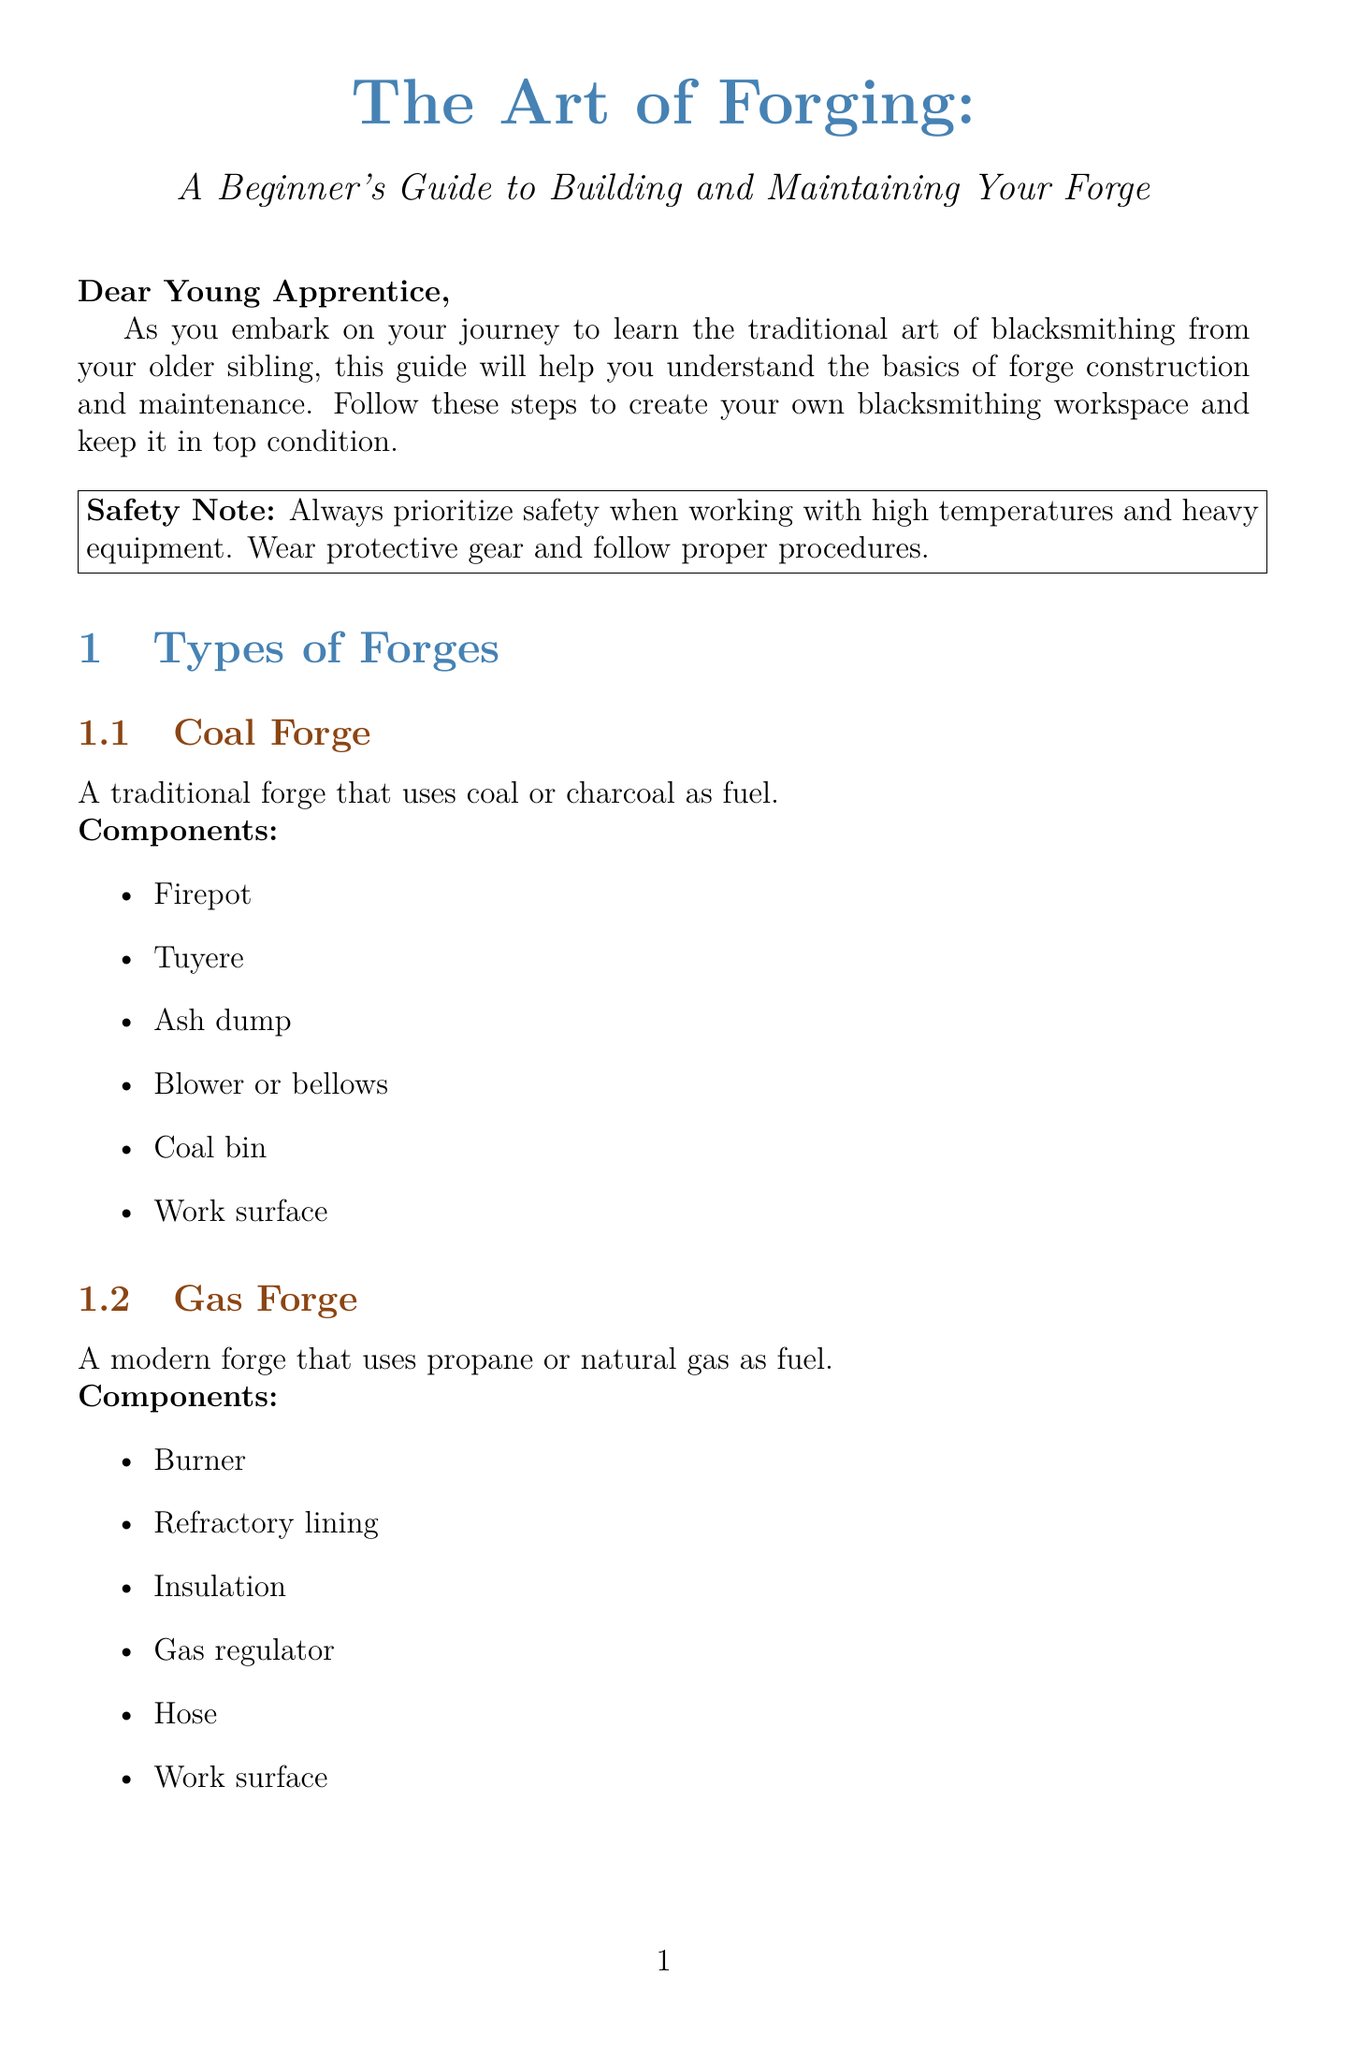What is the title of the guide? The title is provided in the introduction section of the document.
Answer: The Art of Forging: A Beginner's Guide to Building and Maintaining Your Forge How many types of forges are mentioned? The number of forge types is found in the section listing different forge types.
Answer: Two What is the first step in building a forge? The first step is detailed in the building steps section, specifically focusing on the order of tasks.
Answer: Choose Your Forge Type What safety equipment is listed? The safety equipment section enumerates the required protective gear.
Answer: Leather apron What tasks should be performed monthly for maintenance? Monthly tasks are outlined in the maintenance guide section, focusing on regular upkeep actions.
Answer: Check Refractory Lining and Lubricate Moving Parts What causes low heat output? The possible causes are provided in the troubleshooting section for low heat output.
Answer: Insufficient fuel What do you need to gather for constructing a coal forge? The materials needed for a coal forge are specified in the building steps section.
Answer: Firebricks, steel plates, and a blower What should you do to resolve excessive fuel consumption? Solutions for excessive fuel consumption are outlined in the troubleshooting section.
Answer: Add or replace insulation What is the frequency of daily cleaning? The frequency for daily cleaning is noted in the maintenance guide.
Answer: After each use 